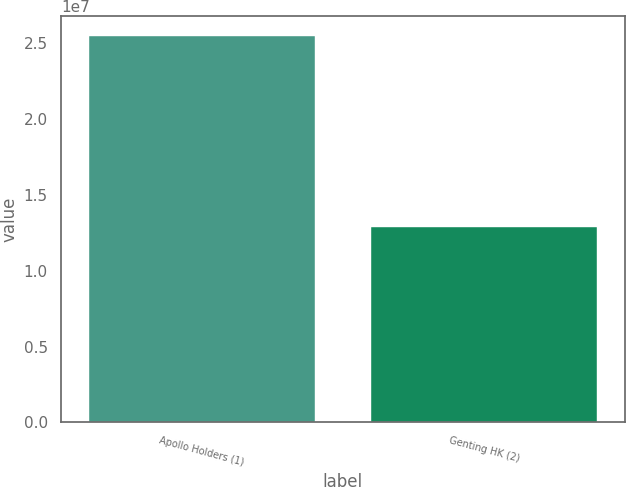Convert chart to OTSL. <chart><loc_0><loc_0><loc_500><loc_500><bar_chart><fcel>Apollo Holders (1)<fcel>Genting HK (2)<nl><fcel>2.54788e+07<fcel>1.28983e+07<nl></chart> 